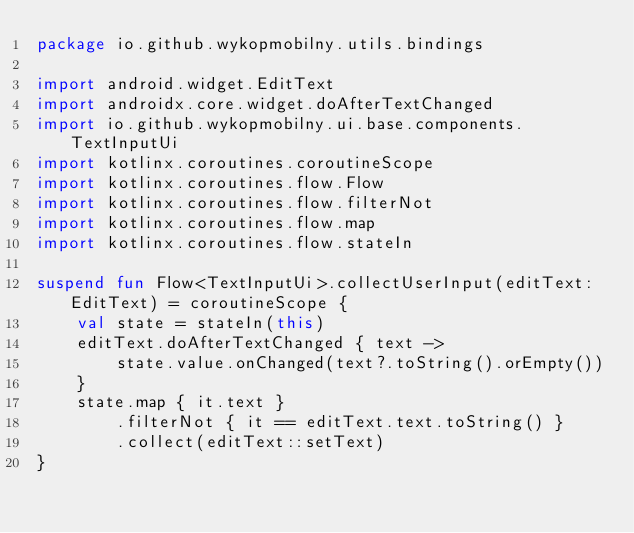<code> <loc_0><loc_0><loc_500><loc_500><_Kotlin_>package io.github.wykopmobilny.utils.bindings

import android.widget.EditText
import androidx.core.widget.doAfterTextChanged
import io.github.wykopmobilny.ui.base.components.TextInputUi
import kotlinx.coroutines.coroutineScope
import kotlinx.coroutines.flow.Flow
import kotlinx.coroutines.flow.filterNot
import kotlinx.coroutines.flow.map
import kotlinx.coroutines.flow.stateIn

suspend fun Flow<TextInputUi>.collectUserInput(editText: EditText) = coroutineScope {
    val state = stateIn(this)
    editText.doAfterTextChanged { text ->
        state.value.onChanged(text?.toString().orEmpty())
    }
    state.map { it.text }
        .filterNot { it == editText.text.toString() }
        .collect(editText::setText)
}
</code> 